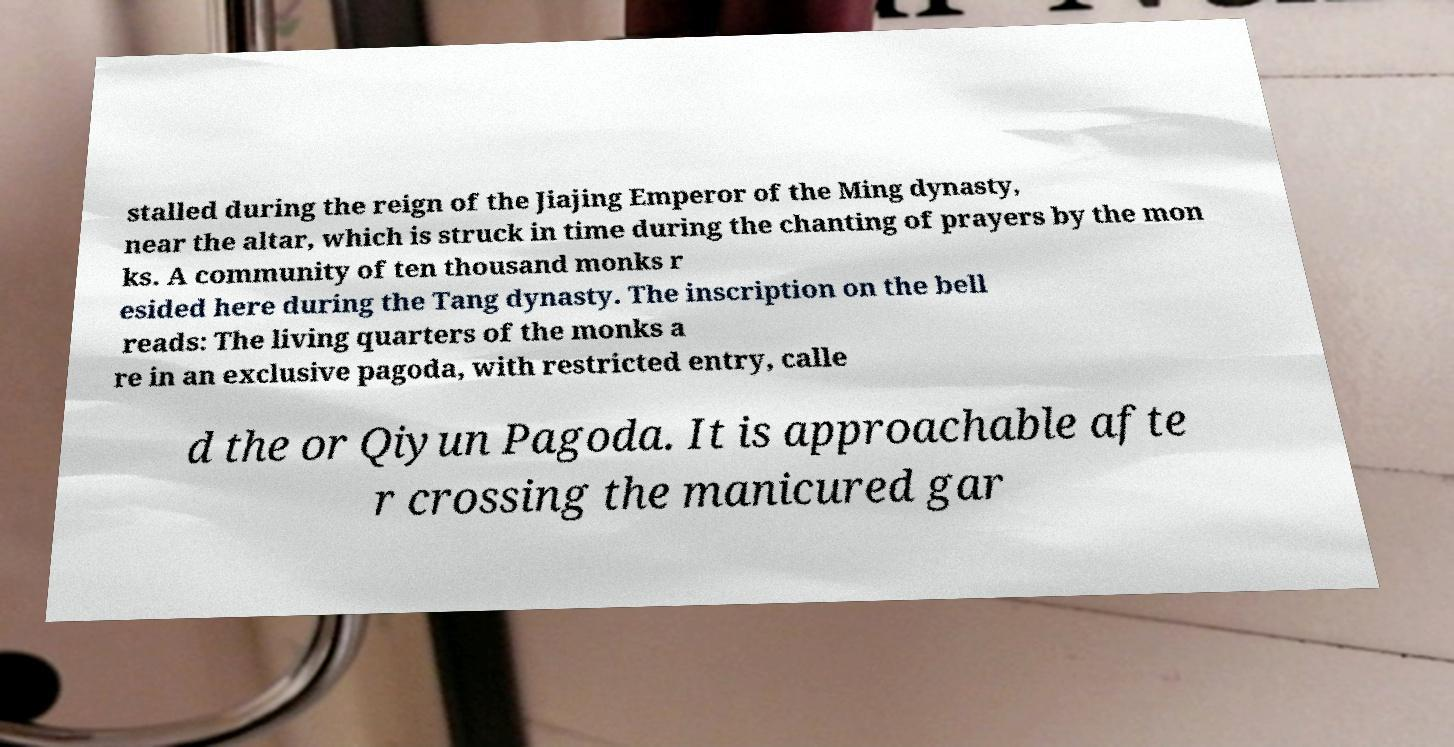Please identify and transcribe the text found in this image. stalled during the reign of the Jiajing Emperor of the Ming dynasty, near the altar, which is struck in time during the chanting of prayers by the mon ks. A community of ten thousand monks r esided here during the Tang dynasty. The inscription on the bell reads: The living quarters of the monks a re in an exclusive pagoda, with restricted entry, calle d the or Qiyun Pagoda. It is approachable afte r crossing the manicured gar 